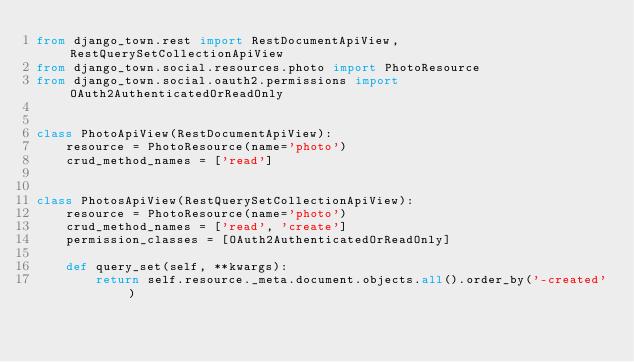Convert code to text. <code><loc_0><loc_0><loc_500><loc_500><_Python_>from django_town.rest import RestDocumentApiView, RestQuerySetCollectionApiView
from django_town.social.resources.photo import PhotoResource
from django_town.social.oauth2.permissions import OAuth2AuthenticatedOrReadOnly


class PhotoApiView(RestDocumentApiView):
    resource = PhotoResource(name='photo')
    crud_method_names = ['read']


class PhotosApiView(RestQuerySetCollectionApiView):
    resource = PhotoResource(name='photo')
    crud_method_names = ['read', 'create']
    permission_classes = [OAuth2AuthenticatedOrReadOnly]

    def query_set(self, **kwargs):
        return self.resource._meta.document.objects.all().order_by('-created')</code> 